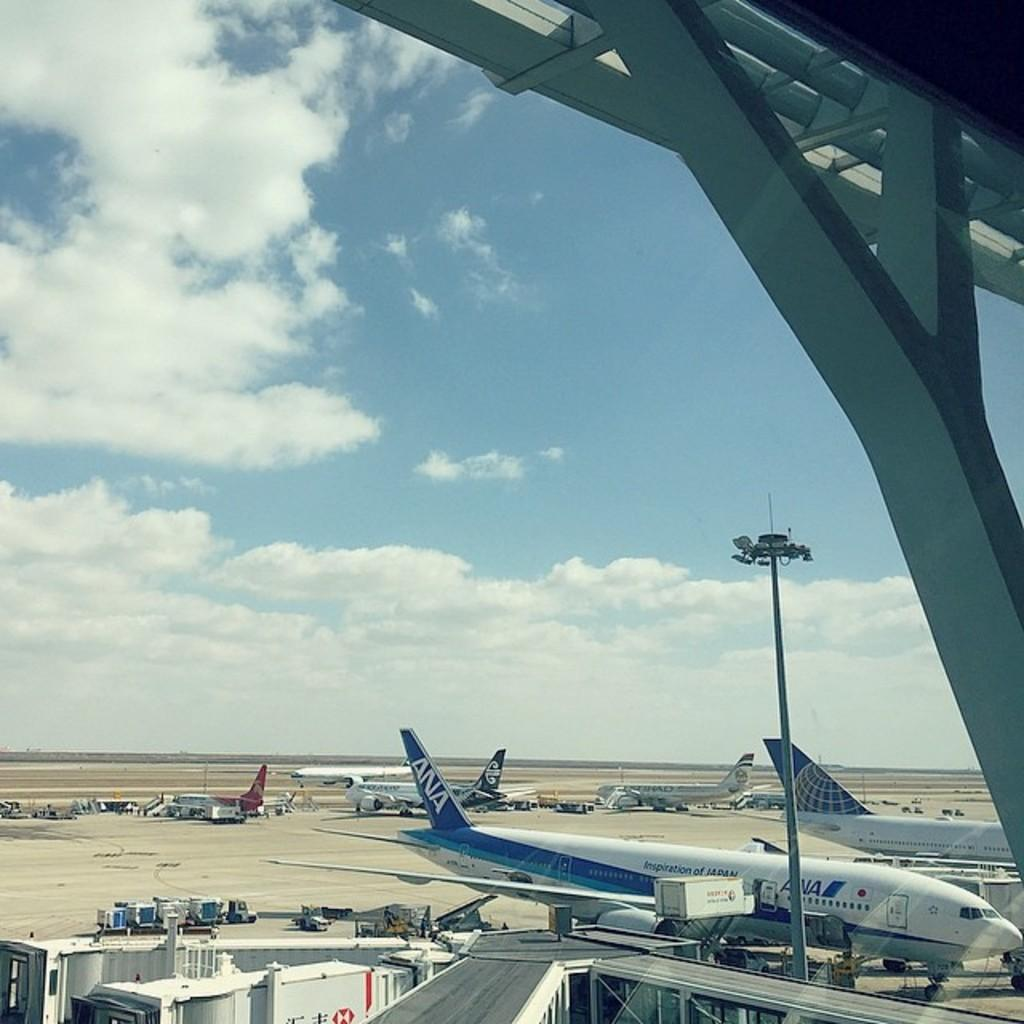What objects can be seen in the front of the image? There are rods, a light pole, planes, and vehicles in the front of the image. What type of transportation is present in the image? Planes and vehicles are present in the image. What is the condition of the sky in the background of the image? The sky appears to be cloudy in the background of the image. Can you describe the objects in the front of the image? There are rods, a light pole, planes, and vehicles, which are all objects visible in the image. How many birds are flying in the image? There are no birds visible in the image. What is the rate of the vehicles moving in the image? The image does not provide information about the rate at which the vehicles are moving. 